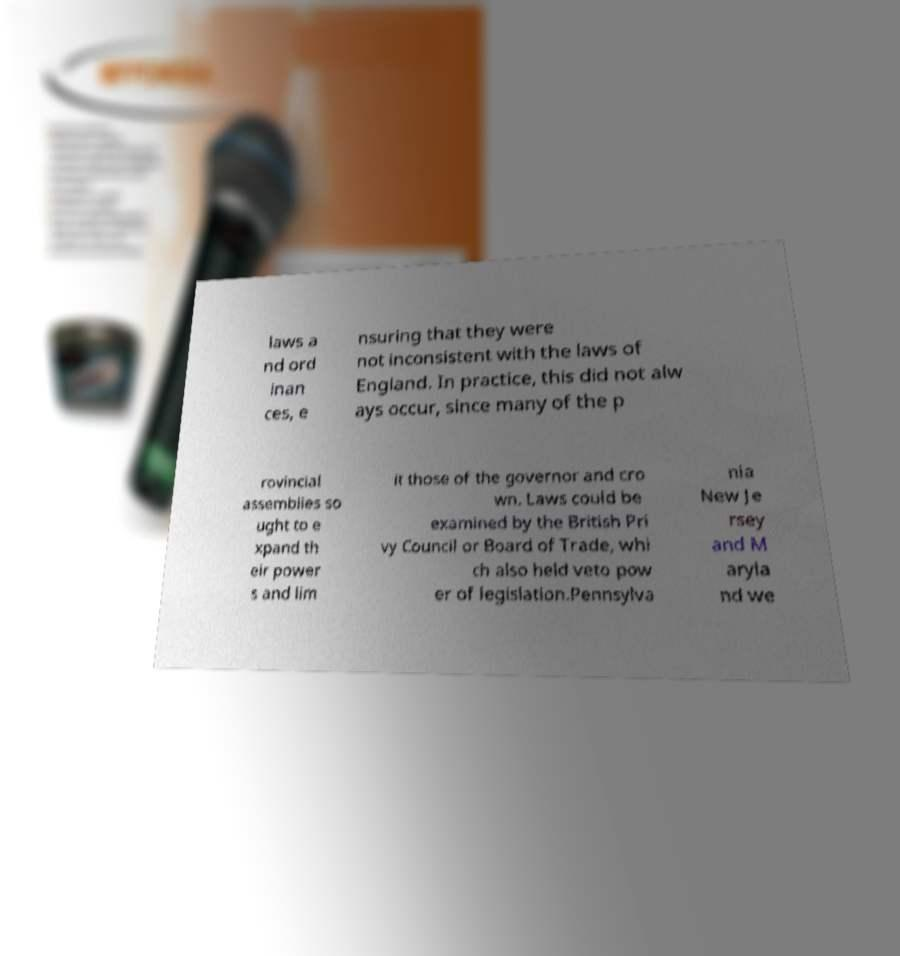For documentation purposes, I need the text within this image transcribed. Could you provide that? laws a nd ord inan ces, e nsuring that they were not inconsistent with the laws of England. In practice, this did not alw ays occur, since many of the p rovincial assemblies so ught to e xpand th eir power s and lim it those of the governor and cro wn. Laws could be examined by the British Pri vy Council or Board of Trade, whi ch also held veto pow er of legislation.Pennsylva nia New Je rsey and M aryla nd we 